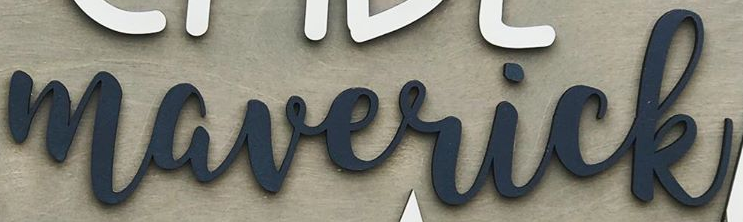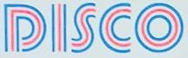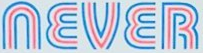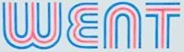What text appears in these images from left to right, separated by a semicolon? maverick; DISCO; NEVER; WENT 